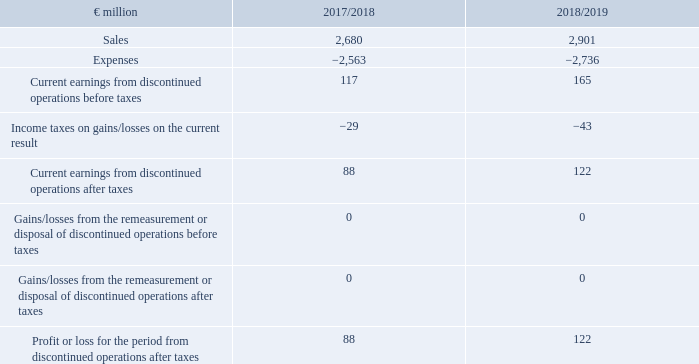Profit or loss for the period after taxes
The current result of METRO China was reclassified in the consolidated income statement under the item ‘profit or loss for the period from discontinued operations after taxes’, taking into account necessary consolidation measures. To increase the economic meaningfulness of the earnings statement of the continuing sector, its shares in the consolidation effects were also included in the discontinued section of the earnings statement as far as they were related to business relations that are to be upheld in the long term even after the planned disposal. The previous year’s figures of the income statement were adjusted accordingly.
Profit or loss for the period from discontinued operations after taxes is attributable to the shareholders of METRO AG in the amount of €118 million (2017/18: €87 million). Noncontrolling interests account for €5 million of earnings (2017/18: €1 million).
In connection with the divestment process, expenses in the low 2-digit million euros range have been incurred to date.
As a result, profit or loss for the period from discontinued operations after taxes is made up as follows for METRO China:
What was done to increase the economic meaningfulness of the earnings statement of the continuing sector? Its shares in the consolidation effects were also included in the discontinued section of the earnings statement as far as they were related to business relations that are to be upheld in the long term even after the planned disposal. How much of earnings does the Noncontrolling interests account for in FY2019? €5 million. What were the components factored in during the calculation of Current earnings from discontinued operations before taxes? Sales, expenses. In which year was Current earnings from discontinued operations after taxes larger? 122>88
Answer: 2019. What was the change in Sales in FY2019 from FY2018?
Answer scale should be: million. 2,901-2,680
Answer: 221. What was the percentage change in Sales in FY2019 from FY2018?
Answer scale should be: percent. (2,901-2,680)/2,680
Answer: 8.25. 